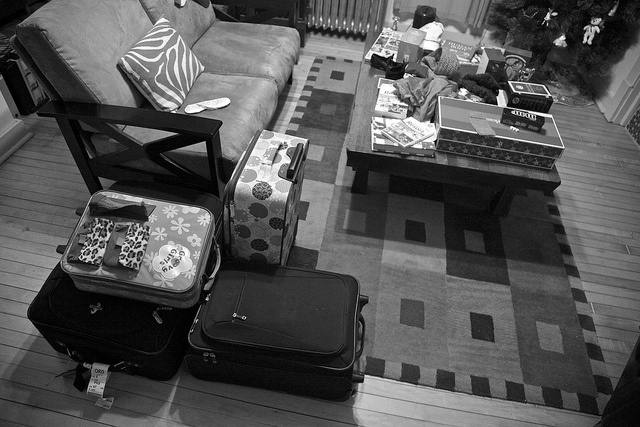Describe the objects in this image and their specific colors. I can see couch in black, darkgray, gray, and lightgray tones, dining table in black, gray, darkgray, and lightgray tones, suitcase in black, gray, and lightgray tones, suitcase in black, darkgray, gray, and lightgray tones, and suitcase in black, gray, darkgray, and lightgray tones in this image. 